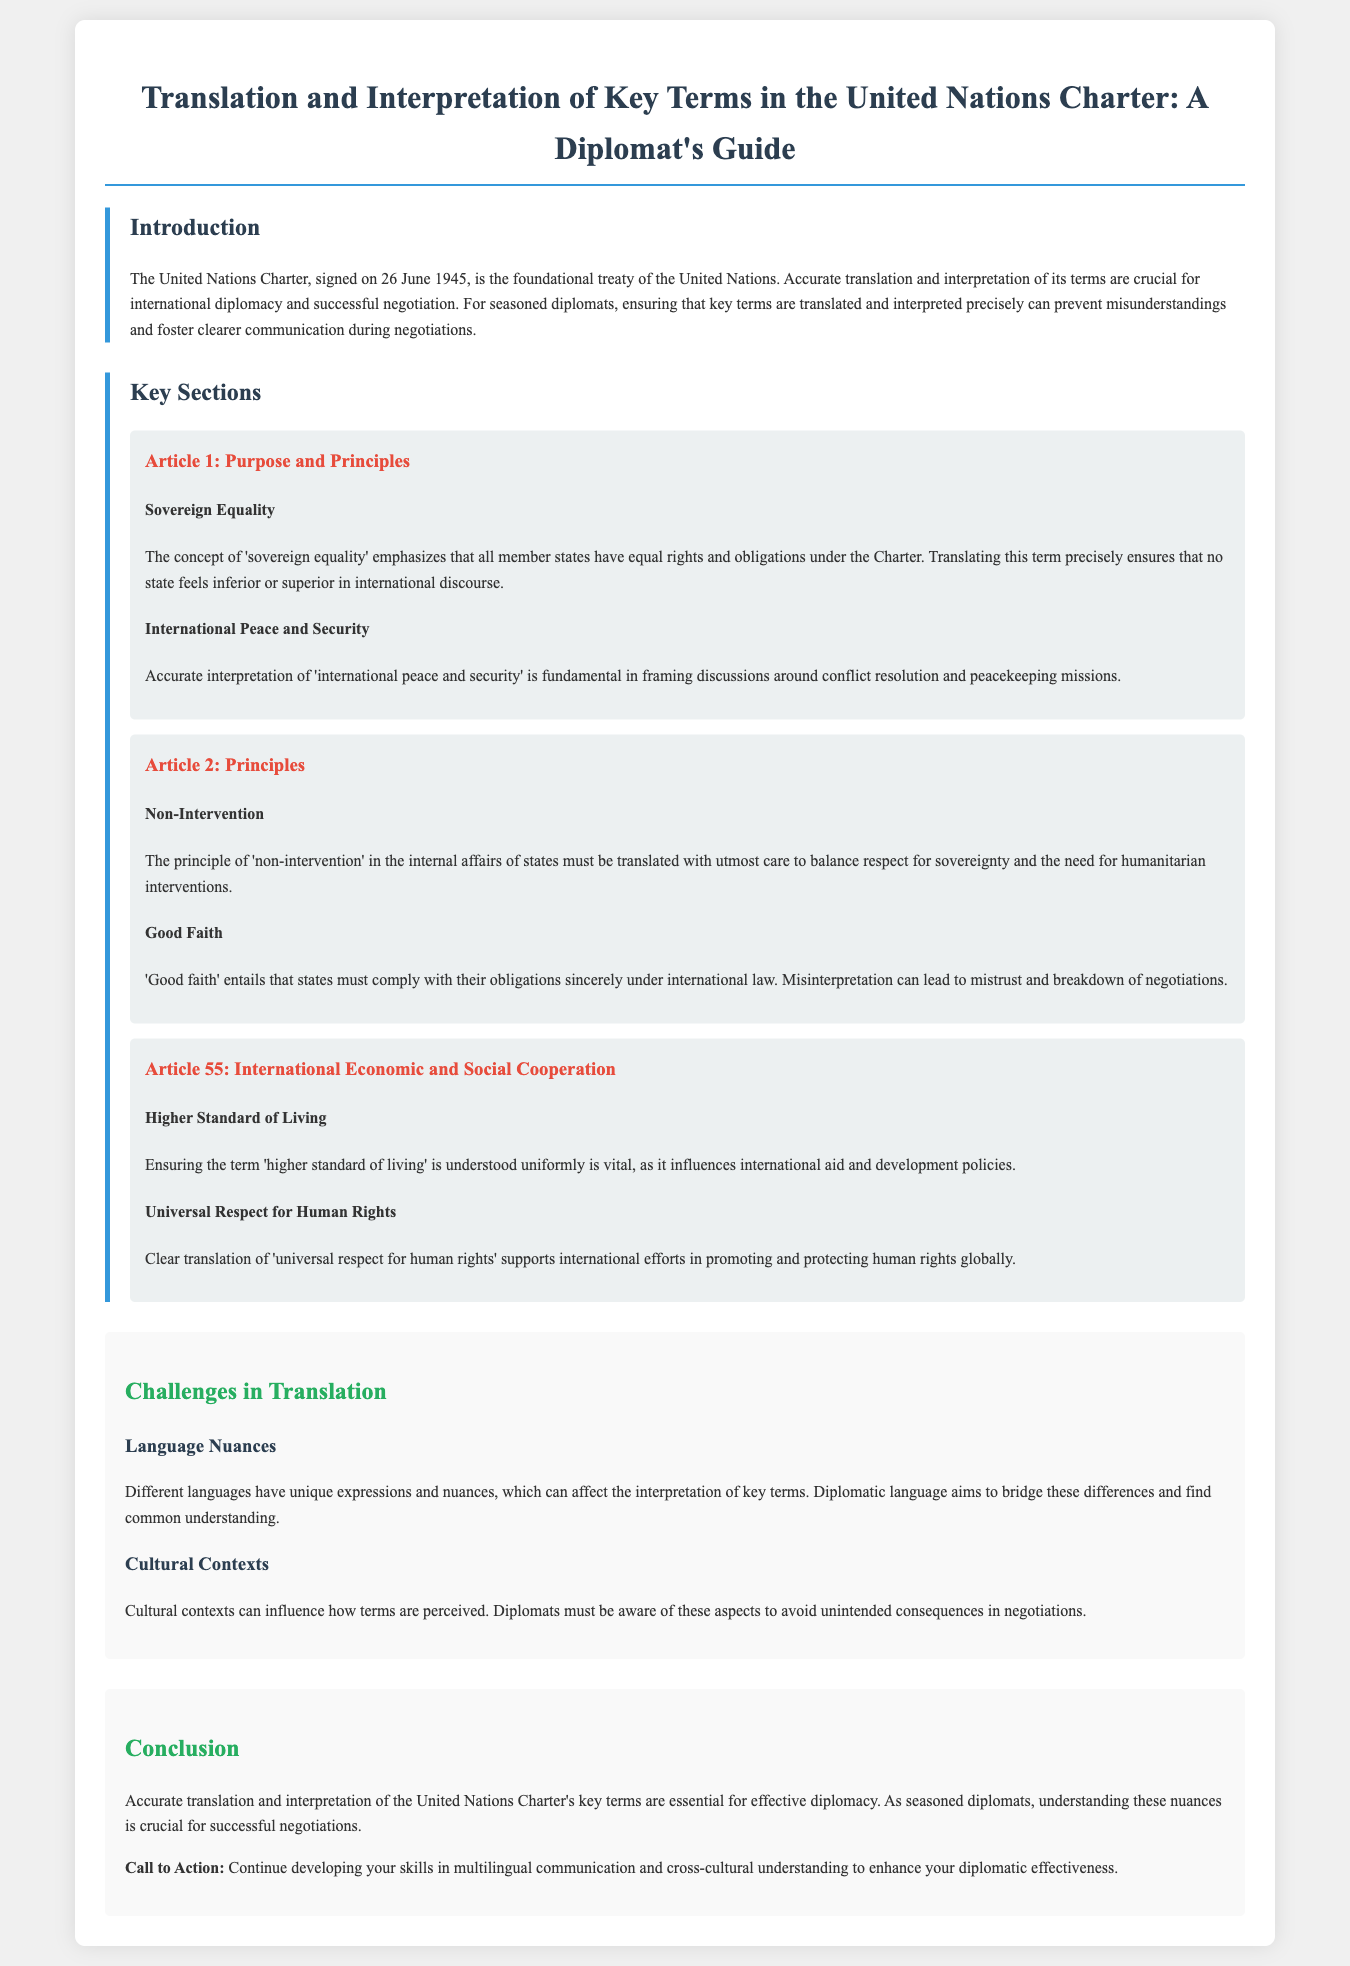What date was the United Nations Charter signed? The document states that the United Nations Charter was signed on 26 June 1945.
Answer: 26 June 1945 What does 'sovereign equality' refer to? The document explains that 'sovereign equality' emphasizes that all member states have equal rights and obligations under the Charter.
Answer: Equal rights and obligations What is a key challenge in translation mentioned in the document? The document identifies 'language nuances' as a challenge that affects the interpretation of key terms.
Answer: Language nuances What term refers to the principle of respect for state sovereignty? The term 'non-intervention' is defined in the document as the principle of respect for state sovereignty.
Answer: Non-intervention What does Article 55 promote regarding living standards? The document states that Article 55 focuses on ensuring a 'higher standard of living.'
Answer: Higher standard of living What is one aspect crucial for successful negotiations according to the conclusion? The conclusion mentions that understanding 'nuances' is crucial for effective diplomacy and negotiations.
Answer: Nuances Which key term addresses the importance of human rights universally? The document highlights 'universal respect for human rights' as a key term associated with promoting human rights globally.
Answer: Universal respect for human rights How many sections are titled 'Key Sections' in the document? The document lists three sections under 'Key Sections' which are Articles 1, 2, and 55.
Answer: Three 